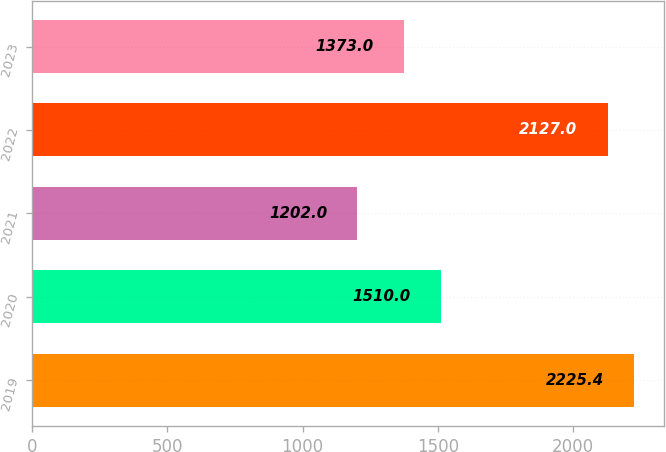Convert chart. <chart><loc_0><loc_0><loc_500><loc_500><bar_chart><fcel>2019<fcel>2020<fcel>2021<fcel>2022<fcel>2023<nl><fcel>2225.4<fcel>1510<fcel>1202<fcel>2127<fcel>1373<nl></chart> 